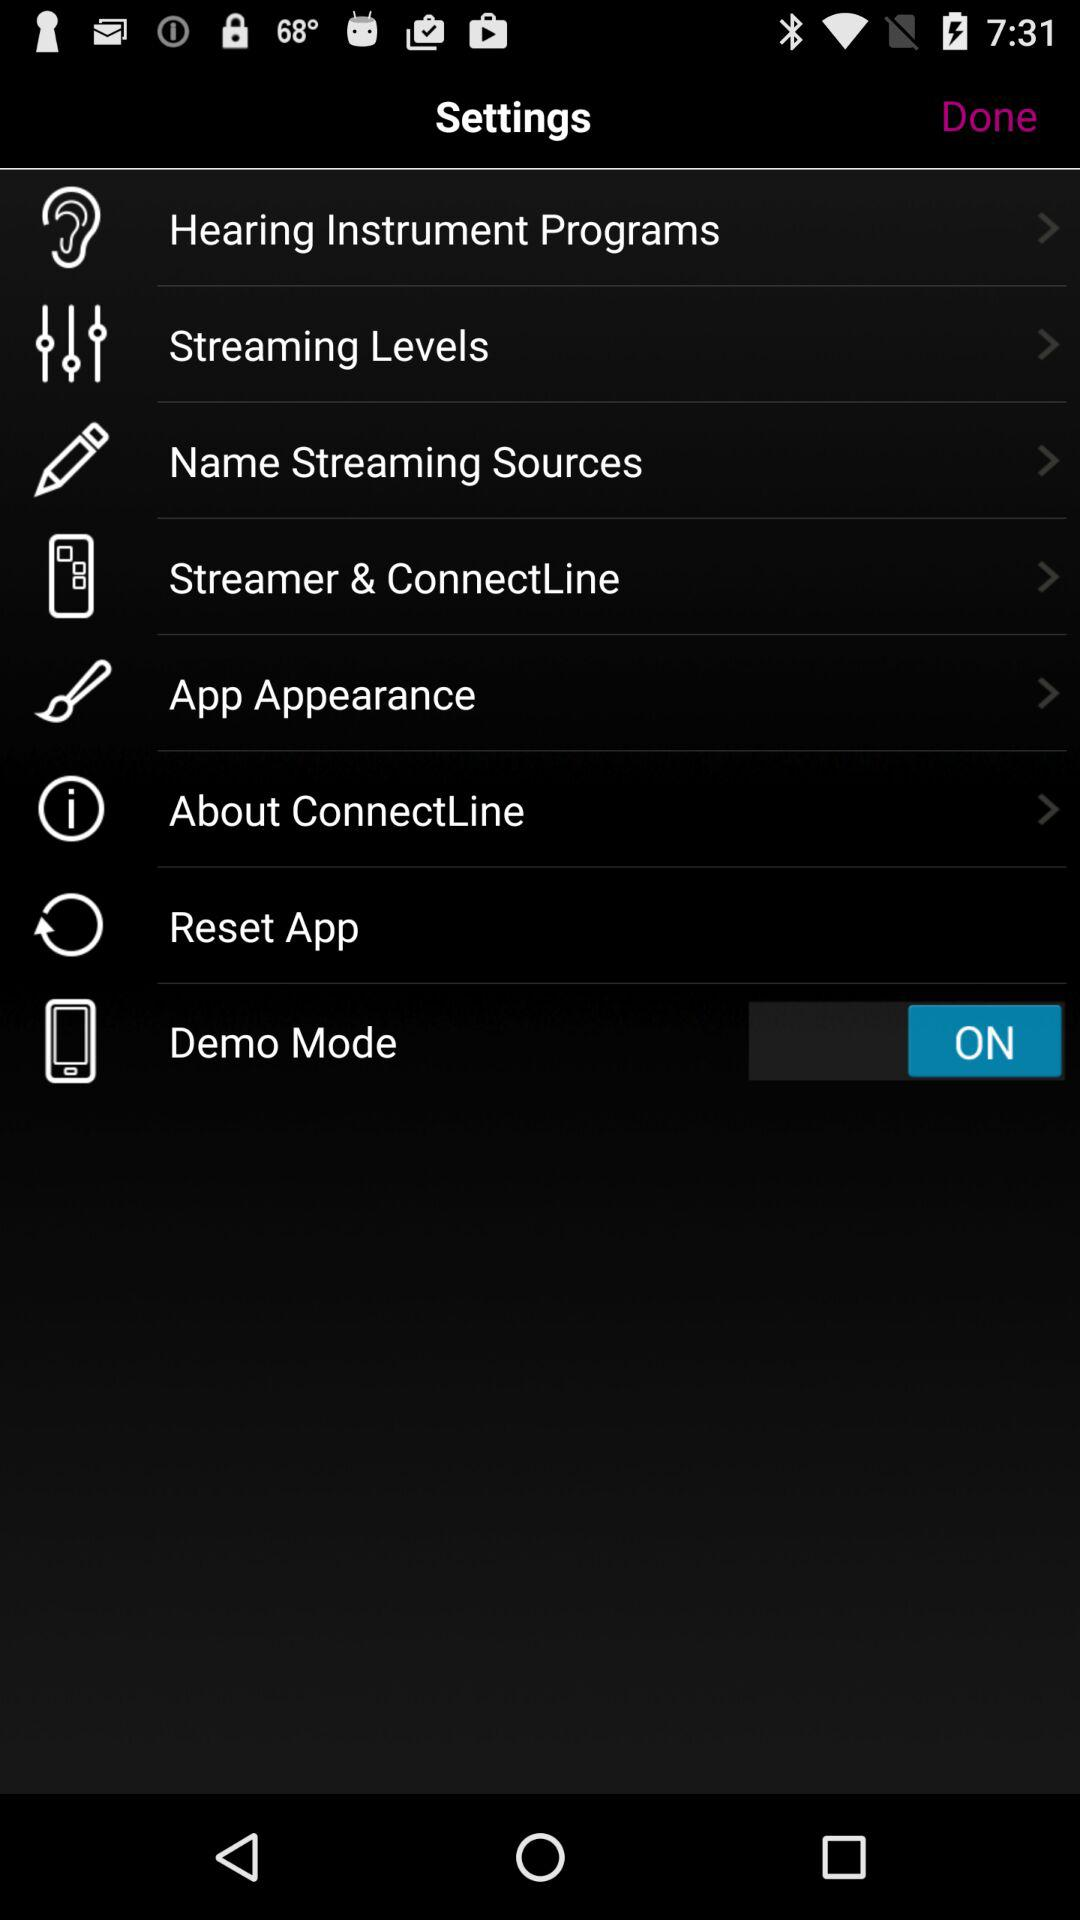What is the status of "Demo Mode"? The status of "Demo Mode" is "on". 